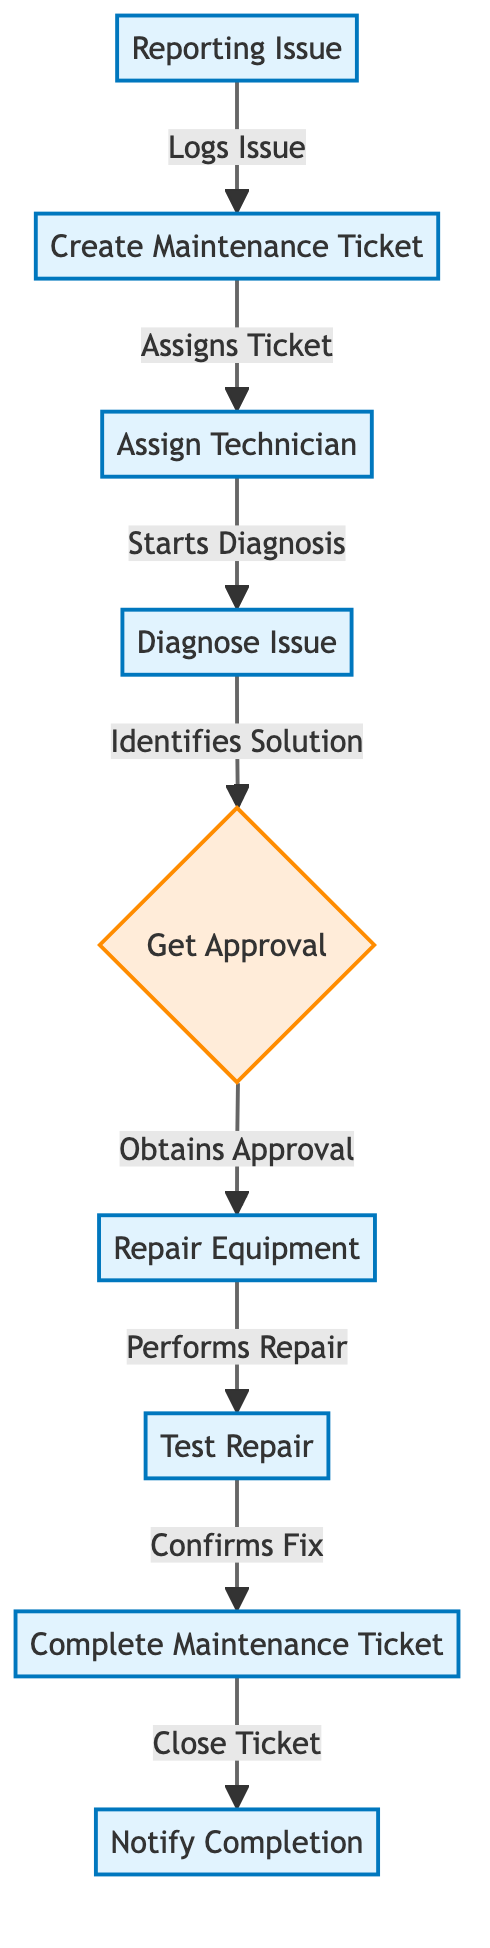What is the first step in the equipment repair process? The first step in the process, as indicated in the diagram, is "Reporting Issue," which is represented as node A. This step initiates the entire workflow for equipment repair.
Answer: Reporting Issue How many main processes are involved in the repair workflow? By counting the distinct process nodes in the diagram, we find there are eight processes, which are "Create Maintenance Ticket," "Assign Technician," "Diagnose Issue," "Repair Equipment," "Test Repair," "Complete Maintenance Ticket," and "Notify Completion."
Answer: Eight What happens after diagnosing the issue? Following the diagnosis of the issue, which is indicated in node D, the next step is to "Get Approval," depicted as decision node E. This indicates that the process moves towards obtaining necessary approval before proceeding further.
Answer: Get Approval How many decision points are there in this workflow? The diagram contains only one decision point, which is "Get Approval" represented as node E. This step determines the next action based on the approval outcome.
Answer: One What is the last action before closing the maintenance ticket? The last action before closing the maintenance ticket, after all repairs are confirmed to be successful, is "Notify Completion," which is represented in the diagram as node I; it signifies the final step in the workflow after ticket completion.
Answer: Notify Completion What must happen after obtaining approval? Once approval is obtained, the workflow indicates that the next step is to "Repair Equipment," as depicted by node F. This confirms that an affirmative decision leads directly to the repairs being executed.
Answer: Repair Equipment Which step directly follows assigning a technician? After assigning a technician, the next direct step is "Diagnose Issue," shown as node D in the diagram. This means that once a technician is assigned, diagnosing the reported issue is their immediate responsibility.
Answer: Diagnose Issue What is shown at the bottom of the workflow? The bottom of the workflow diagram shows the "Notify Completion" step, which indicates that all procedures have concluded and the maintenance ticket can be communicated as completed.
Answer: Notify Completion 